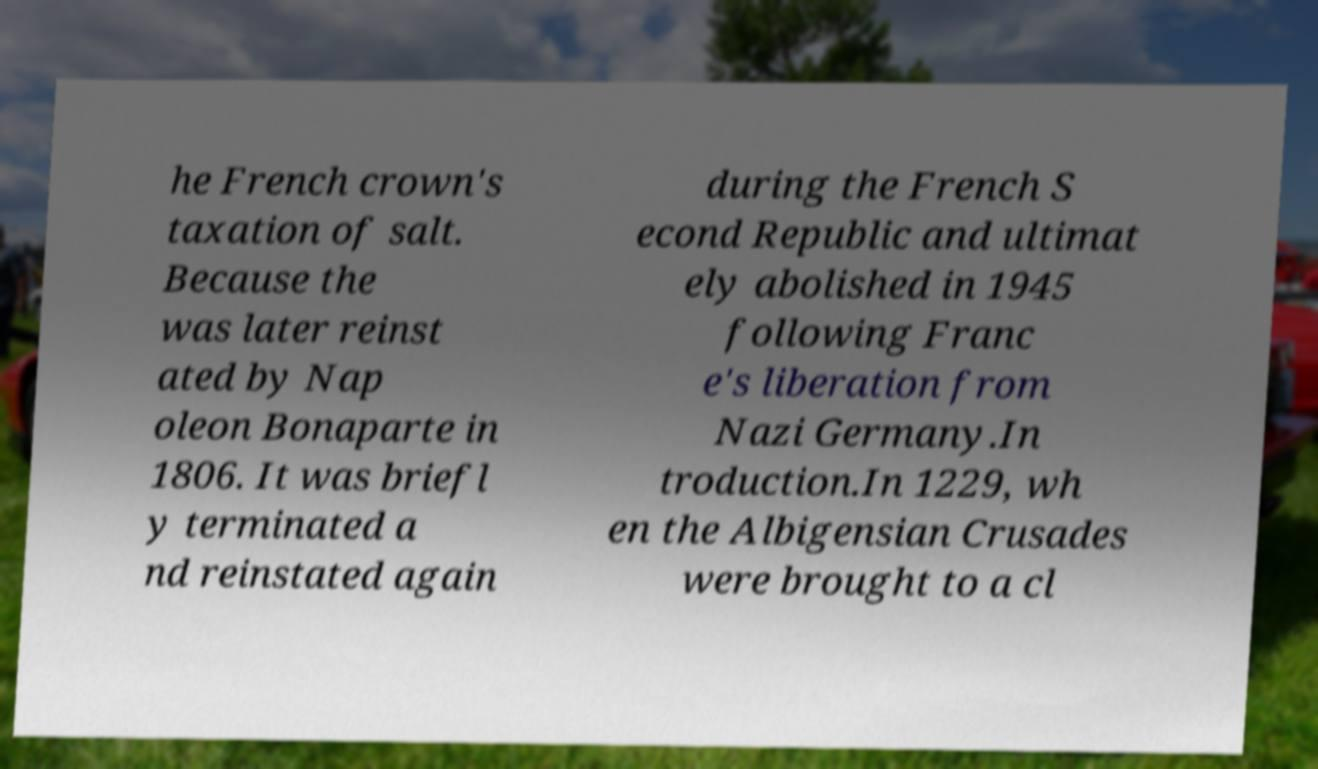I need the written content from this picture converted into text. Can you do that? he French crown's taxation of salt. Because the was later reinst ated by Nap oleon Bonaparte in 1806. It was briefl y terminated a nd reinstated again during the French S econd Republic and ultimat ely abolished in 1945 following Franc e's liberation from Nazi Germany.In troduction.In 1229, wh en the Albigensian Crusades were brought to a cl 